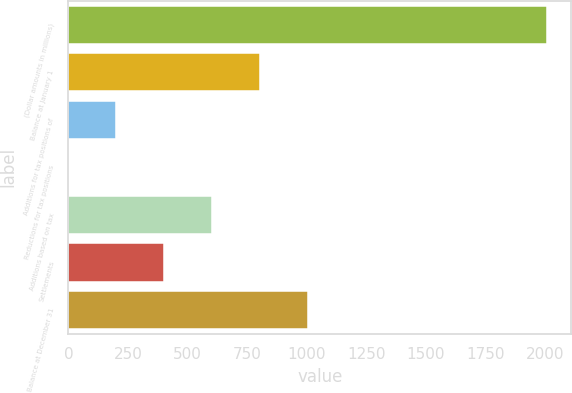Convert chart. <chart><loc_0><loc_0><loc_500><loc_500><bar_chart><fcel>(Dollar amounts in millions)<fcel>Balance at January 1<fcel>Additions for tax positions of<fcel>Reductions for tax positions<fcel>Additions based on tax<fcel>Settlements<fcel>Balance at December 31<nl><fcel>2009<fcel>804.2<fcel>201.8<fcel>1<fcel>603.4<fcel>402.6<fcel>1005<nl></chart> 